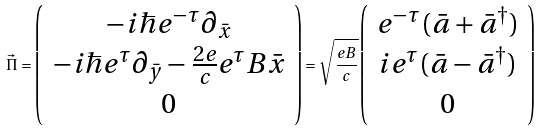Convert formula to latex. <formula><loc_0><loc_0><loc_500><loc_500>\vec { \Pi } = \left ( \begin{array} { c } - i \hbar { e } ^ { - \tau } { \partial } _ { \bar { x } } \\ - i \hbar { e } ^ { \tau } { \partial } _ { \bar { y } } - \frac { 2 e } { c } e ^ { \tau } B \bar { x } \\ 0 \end{array} \right ) = \sqrt { \frac { e B } { c } } \left ( \begin{array} { c } e ^ { - \tau } ( \bar { a } + \bar { a } ^ { \dagger } ) \\ i e ^ { \tau } ( \bar { a } - \bar { a } ^ { \dagger } ) \\ 0 \end{array} \right )</formula> 